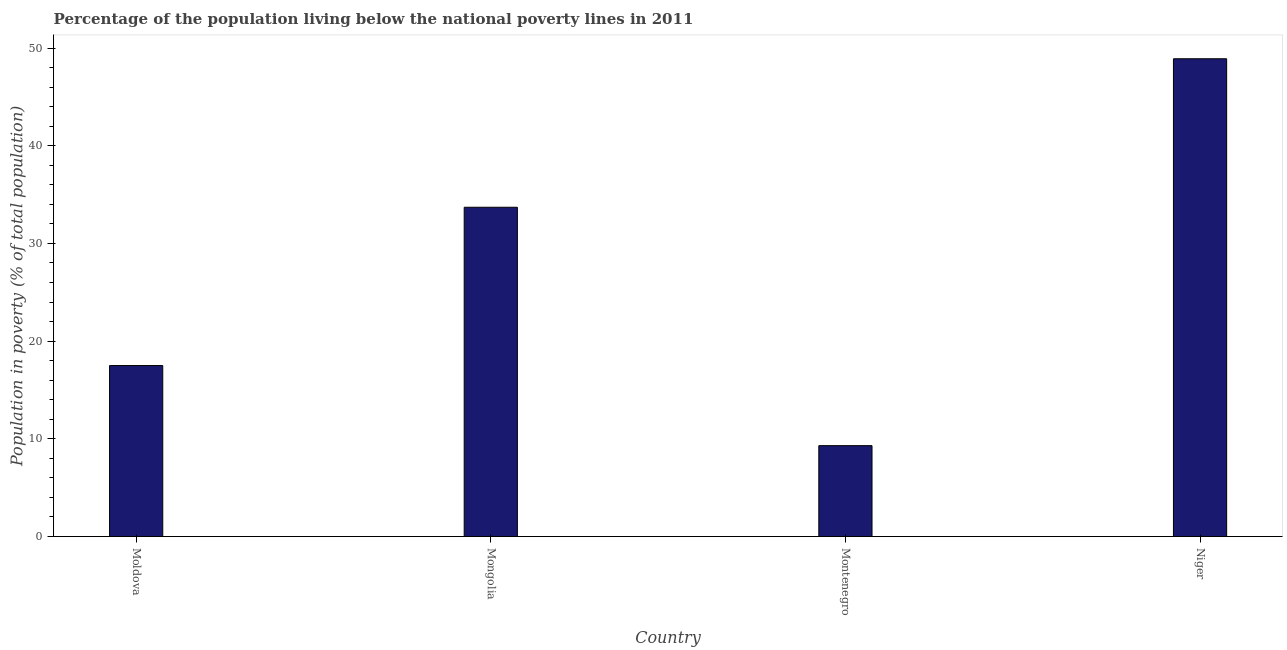What is the title of the graph?
Offer a very short reply. Percentage of the population living below the national poverty lines in 2011. What is the label or title of the X-axis?
Keep it short and to the point. Country. What is the label or title of the Y-axis?
Offer a very short reply. Population in poverty (% of total population). What is the percentage of population living below poverty line in Mongolia?
Give a very brief answer. 33.7. Across all countries, what is the maximum percentage of population living below poverty line?
Offer a terse response. 48.9. Across all countries, what is the minimum percentage of population living below poverty line?
Make the answer very short. 9.3. In which country was the percentage of population living below poverty line maximum?
Offer a terse response. Niger. In which country was the percentage of population living below poverty line minimum?
Provide a short and direct response. Montenegro. What is the sum of the percentage of population living below poverty line?
Offer a terse response. 109.4. What is the average percentage of population living below poverty line per country?
Give a very brief answer. 27.35. What is the median percentage of population living below poverty line?
Offer a very short reply. 25.6. In how many countries, is the percentage of population living below poverty line greater than 2 %?
Provide a short and direct response. 4. What is the ratio of the percentage of population living below poverty line in Mongolia to that in Niger?
Your response must be concise. 0.69. Is the percentage of population living below poverty line in Mongolia less than that in Montenegro?
Offer a very short reply. No. Is the difference between the percentage of population living below poverty line in Moldova and Mongolia greater than the difference between any two countries?
Your answer should be compact. No. What is the difference between the highest and the second highest percentage of population living below poverty line?
Your response must be concise. 15.2. Is the sum of the percentage of population living below poverty line in Moldova and Montenegro greater than the maximum percentage of population living below poverty line across all countries?
Offer a very short reply. No. What is the difference between the highest and the lowest percentage of population living below poverty line?
Your answer should be compact. 39.6. How many bars are there?
Provide a succinct answer. 4. Are all the bars in the graph horizontal?
Offer a very short reply. No. How many countries are there in the graph?
Provide a succinct answer. 4. What is the difference between two consecutive major ticks on the Y-axis?
Provide a succinct answer. 10. What is the Population in poverty (% of total population) in Moldova?
Your answer should be very brief. 17.5. What is the Population in poverty (% of total population) of Mongolia?
Offer a very short reply. 33.7. What is the Population in poverty (% of total population) of Montenegro?
Give a very brief answer. 9.3. What is the Population in poverty (% of total population) in Niger?
Your response must be concise. 48.9. What is the difference between the Population in poverty (% of total population) in Moldova and Mongolia?
Give a very brief answer. -16.2. What is the difference between the Population in poverty (% of total population) in Moldova and Niger?
Provide a short and direct response. -31.4. What is the difference between the Population in poverty (% of total population) in Mongolia and Montenegro?
Offer a terse response. 24.4. What is the difference between the Population in poverty (% of total population) in Mongolia and Niger?
Offer a terse response. -15.2. What is the difference between the Population in poverty (% of total population) in Montenegro and Niger?
Offer a terse response. -39.6. What is the ratio of the Population in poverty (% of total population) in Moldova to that in Mongolia?
Your answer should be compact. 0.52. What is the ratio of the Population in poverty (% of total population) in Moldova to that in Montenegro?
Offer a very short reply. 1.88. What is the ratio of the Population in poverty (% of total population) in Moldova to that in Niger?
Provide a short and direct response. 0.36. What is the ratio of the Population in poverty (% of total population) in Mongolia to that in Montenegro?
Give a very brief answer. 3.62. What is the ratio of the Population in poverty (% of total population) in Mongolia to that in Niger?
Your response must be concise. 0.69. What is the ratio of the Population in poverty (% of total population) in Montenegro to that in Niger?
Your response must be concise. 0.19. 